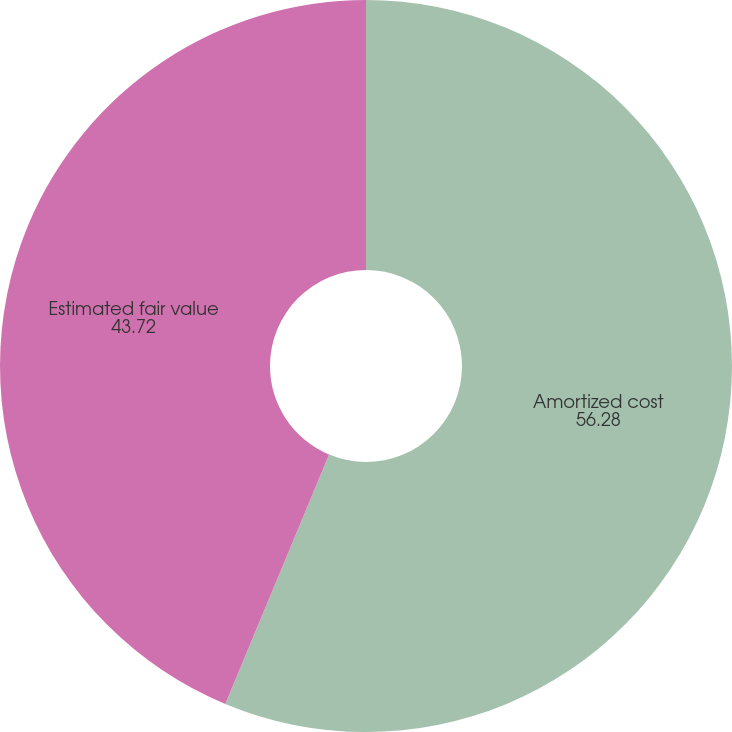<chart> <loc_0><loc_0><loc_500><loc_500><pie_chart><fcel>Amortized cost<fcel>Estimated fair value<nl><fcel>56.28%<fcel>43.72%<nl></chart> 